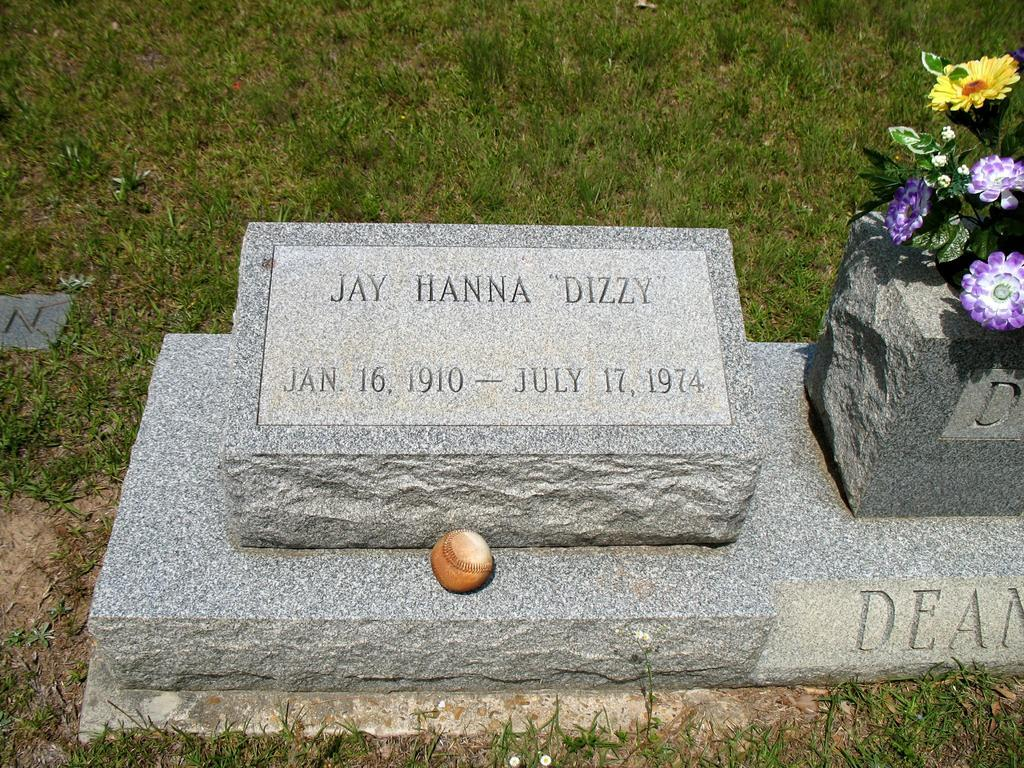What is the main object in the picture? There is a tombstone in the picture. What other object can be seen in the picture? There is a ball in the picture. What decorative items are on the tombstone? Artificial flowers are present on the tombstone. What type of natural environment is visible in the picture? There is grass at the bottom of the picture. What type of question is being asked in the picture? There is no question being asked in the picture; it features a tombstone, a ball, artificial flowers, and grass. What type of amusement can be seen in the picture? There is no amusement present in the picture; it features a tombstone, a ball, artificial flowers, and grass. 